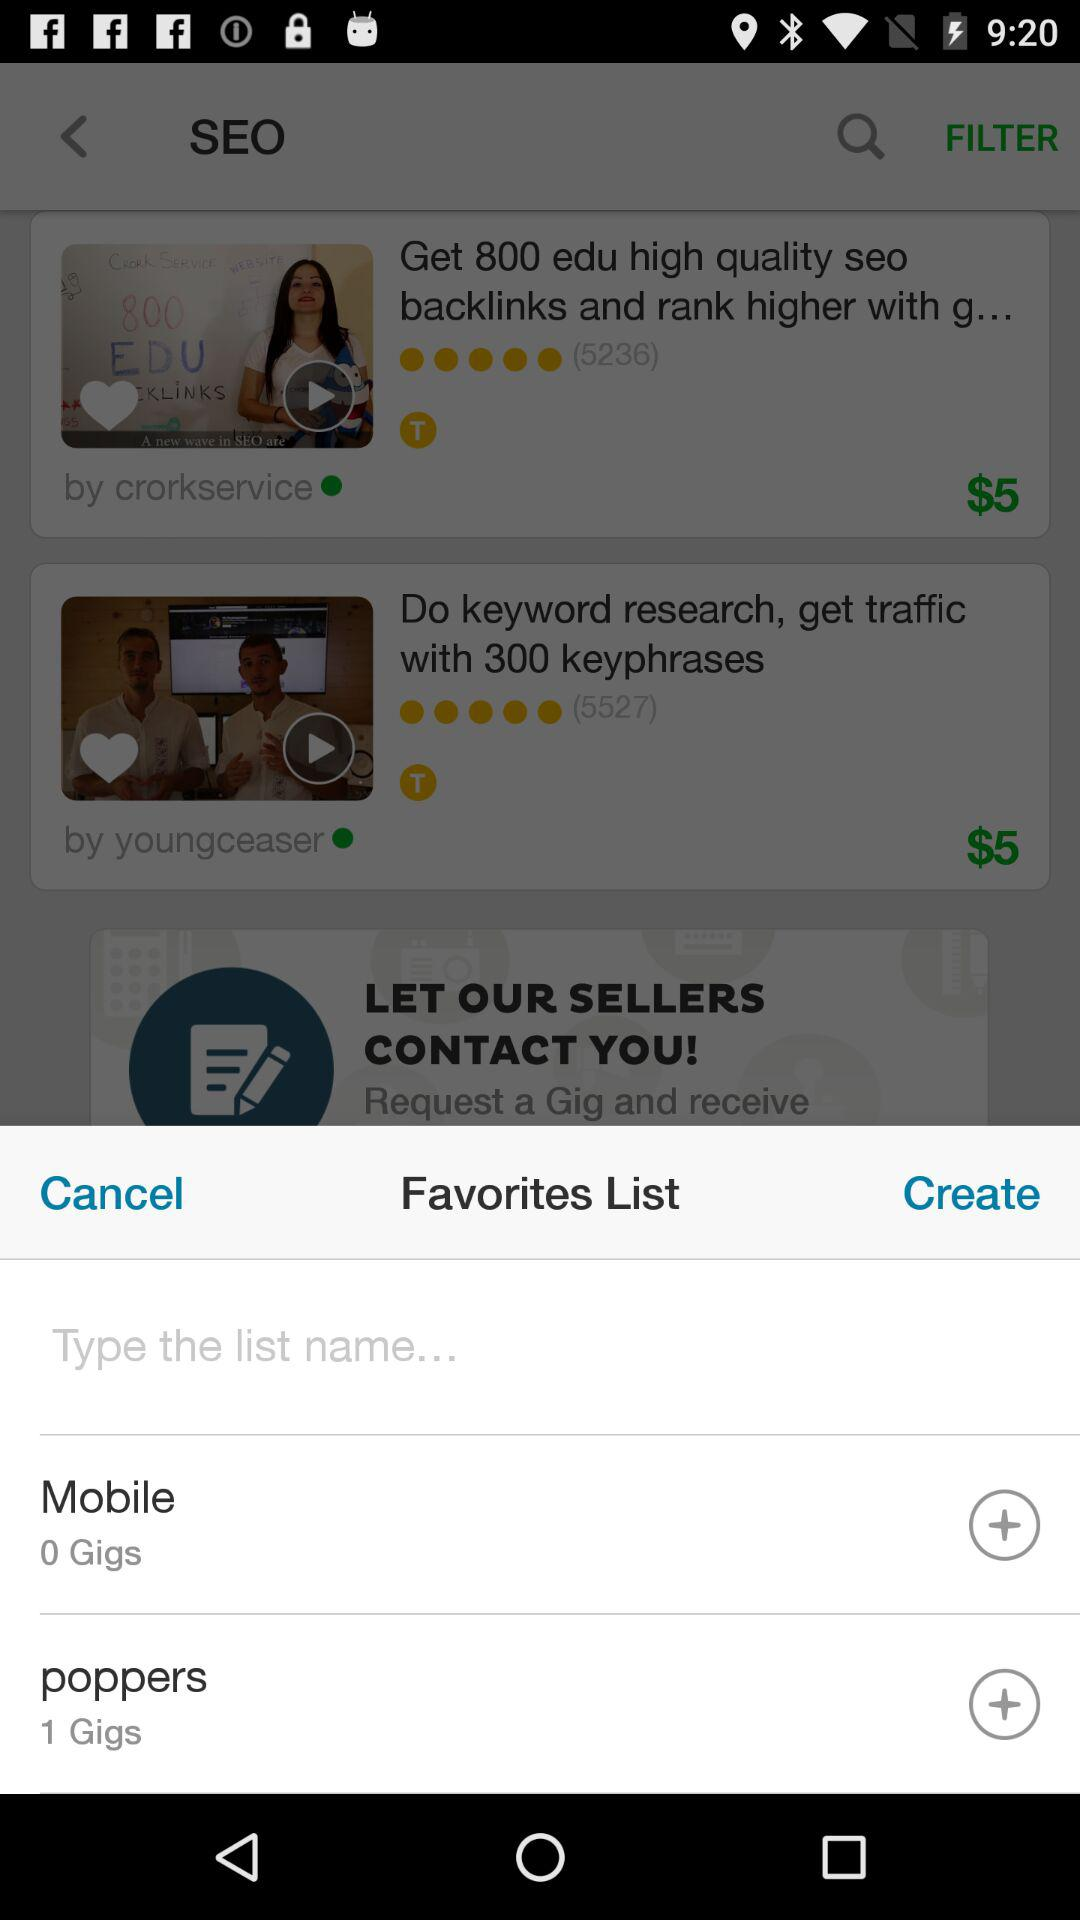By which company was "Get 800 edu high quality seo backlinks and rank higher with g..." posted? "Get 800 edu high quality seo backlinks and rank higher with g..." was posted by "crorkservice". 